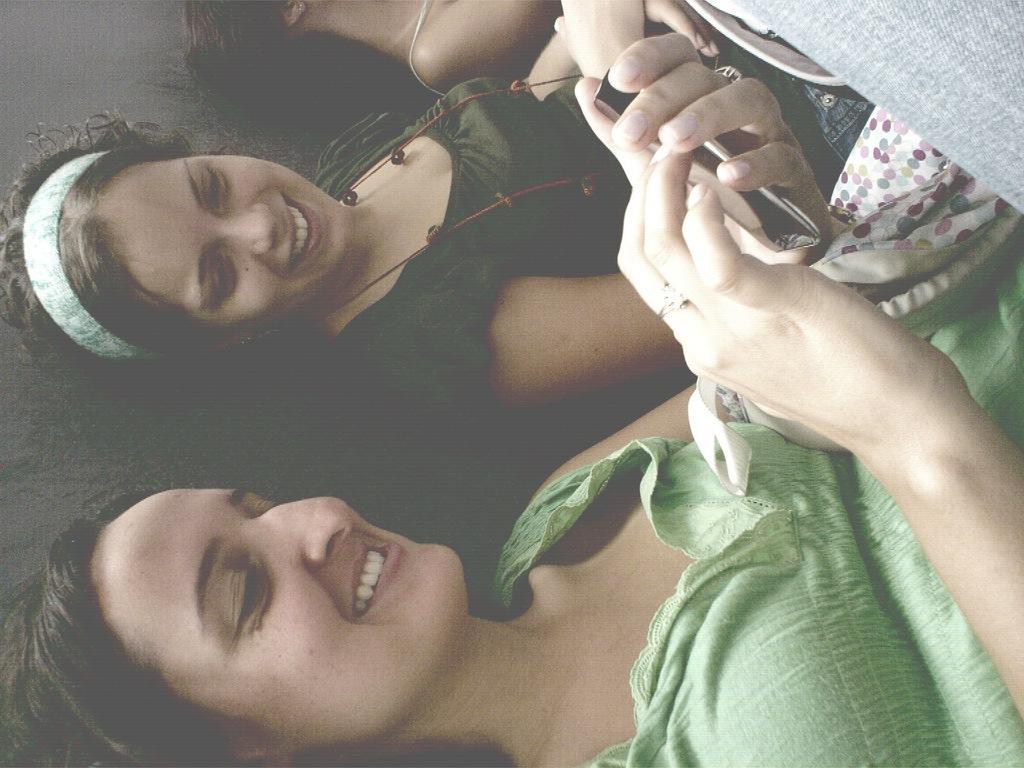In one or two sentences, can you explain what this image depicts? In this picture we can see two women are sitting and watching mobile. 